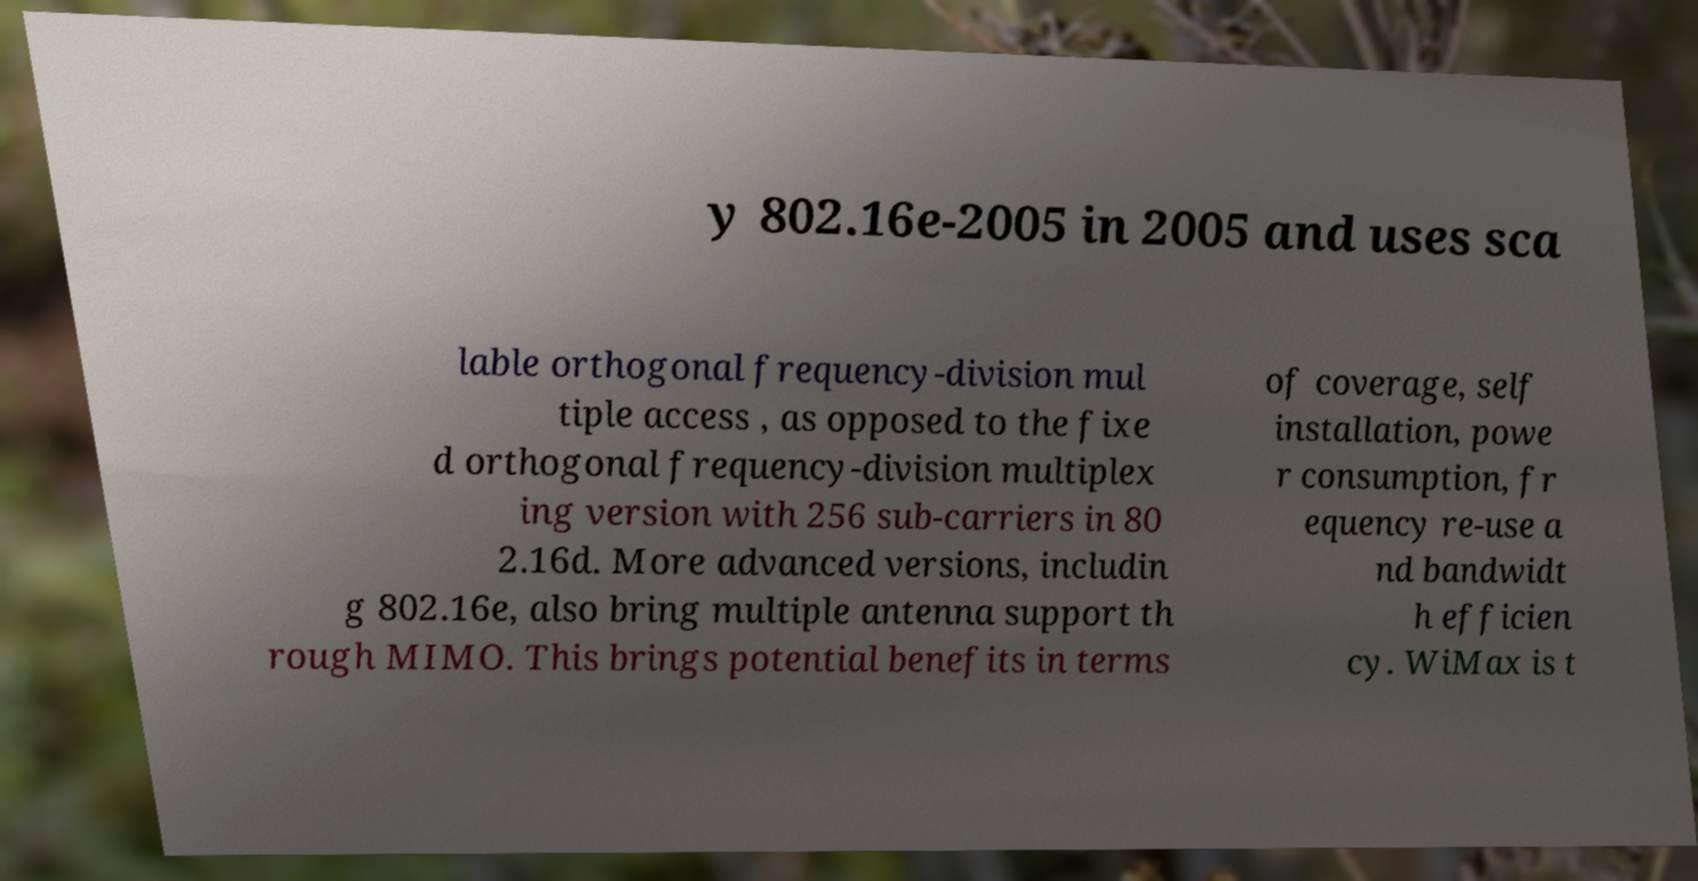What messages or text are displayed in this image? I need them in a readable, typed format. y 802.16e-2005 in 2005 and uses sca lable orthogonal frequency-division mul tiple access , as opposed to the fixe d orthogonal frequency-division multiplex ing version with 256 sub-carriers in 80 2.16d. More advanced versions, includin g 802.16e, also bring multiple antenna support th rough MIMO. This brings potential benefits in terms of coverage, self installation, powe r consumption, fr equency re-use a nd bandwidt h efficien cy. WiMax is t 